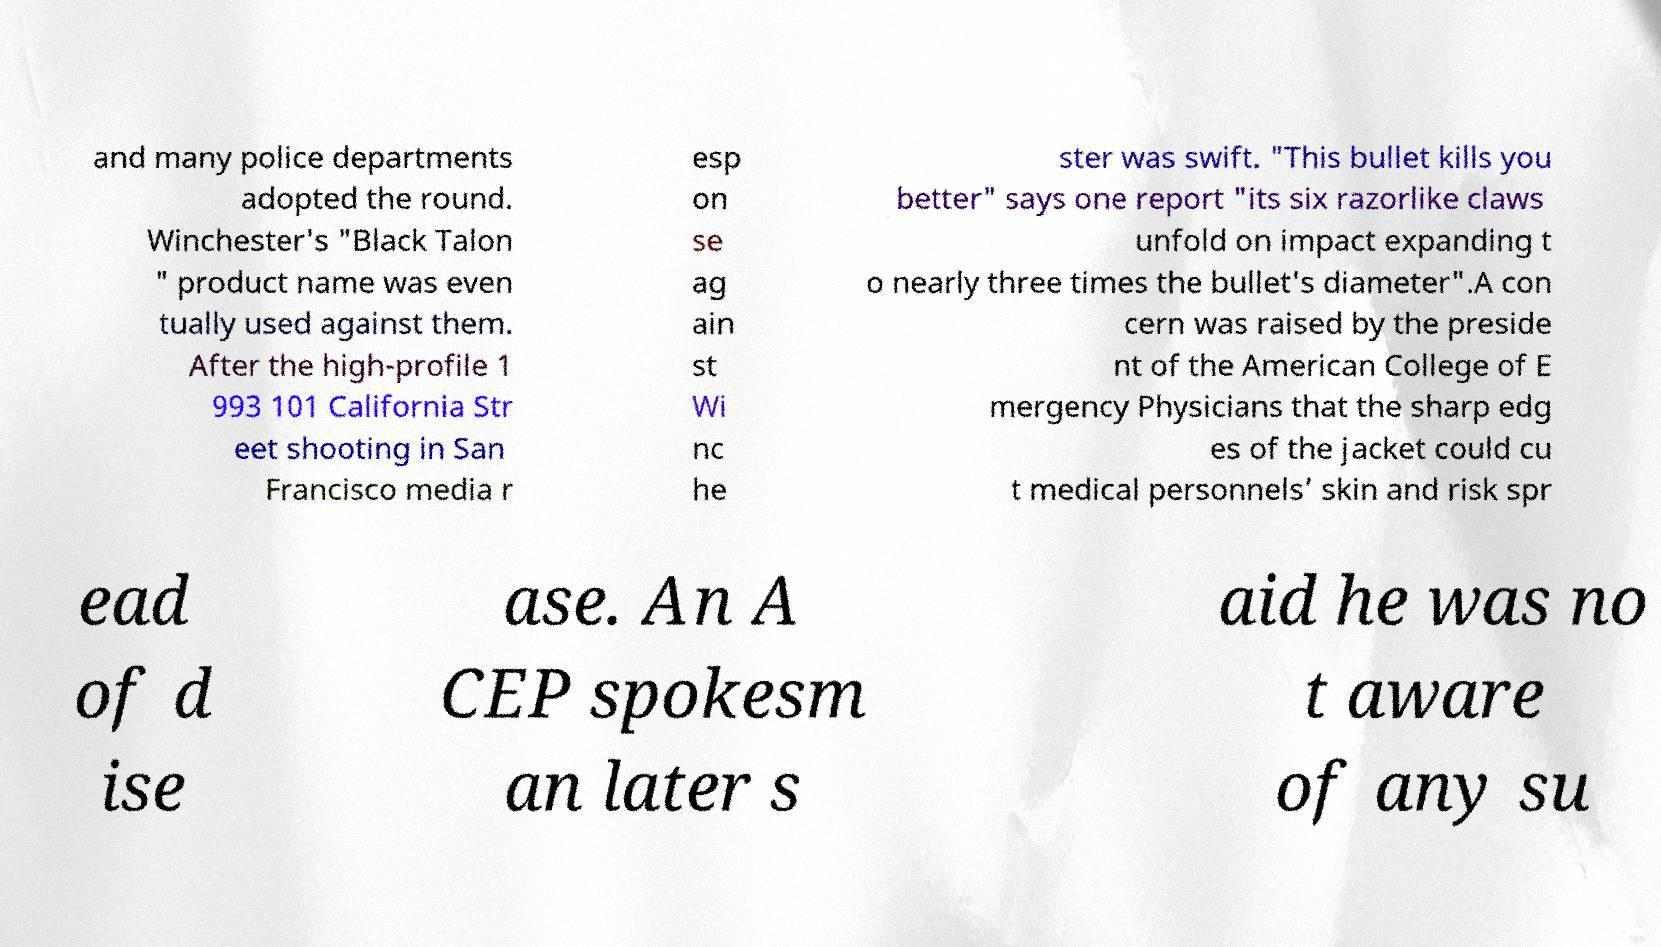What messages or text are displayed in this image? I need them in a readable, typed format. and many police departments adopted the round. Winchester's "Black Talon " product name was even tually used against them. After the high-profile 1 993 101 California Str eet shooting in San Francisco media r esp on se ag ain st Wi nc he ster was swift. "This bullet kills you better" says one report "its six razorlike claws unfold on impact expanding t o nearly three times the bullet's diameter".A con cern was raised by the preside nt of the American College of E mergency Physicians that the sharp edg es of the jacket could cu t medical personnels’ skin and risk spr ead of d ise ase. An A CEP spokesm an later s aid he was no t aware of any su 